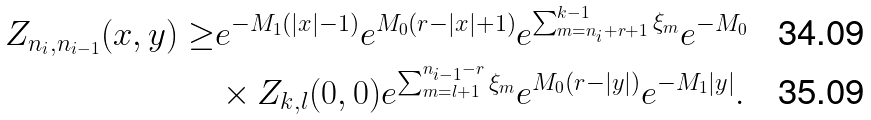<formula> <loc_0><loc_0><loc_500><loc_500>Z _ { n _ { i } , n _ { i - 1 } } ( x , y ) \geq & e ^ { - M _ { 1 } ( | x | - 1 ) } e ^ { M _ { 0 } ( r - | x | + 1 ) } e ^ { \sum _ { m = n _ { i } + r + 1 } ^ { k - 1 } \xi _ { m } } e ^ { - M _ { 0 } } \\ & \times Z _ { k , l } ( 0 , 0 ) e ^ { \sum _ { m = l + 1 } ^ { n _ { i - 1 } - r } \xi _ { m } } e ^ { M _ { 0 } ( r - | y | ) } e ^ { - M _ { 1 } | y | } .</formula> 